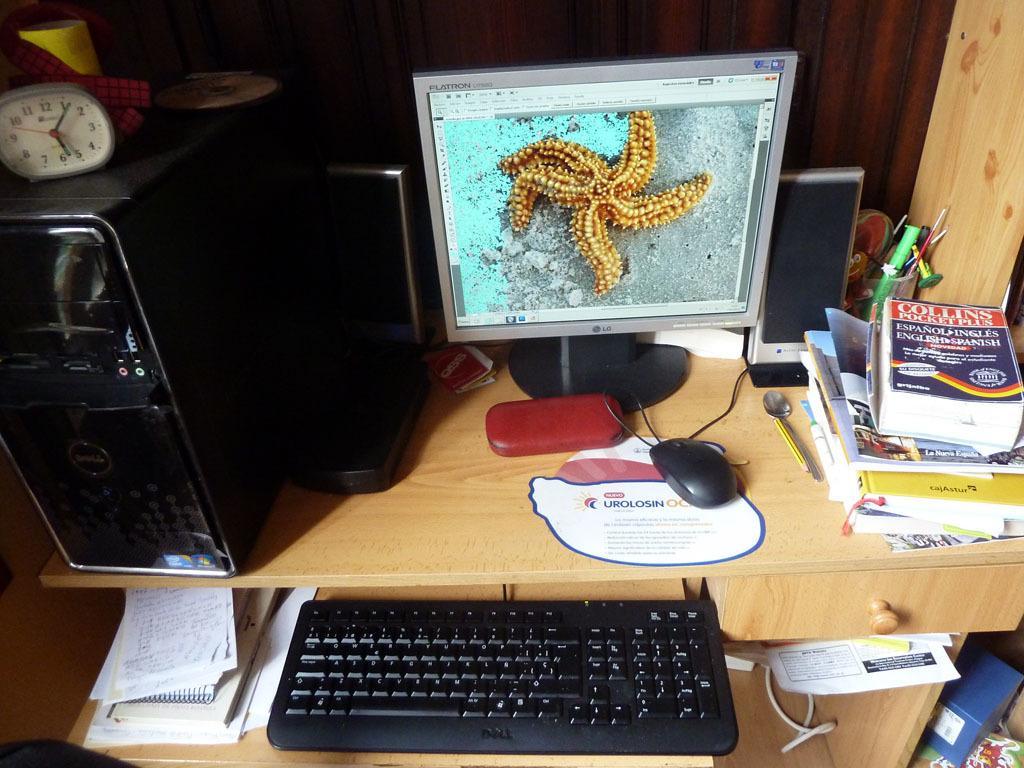Please provide a concise description of this image. In this picture we can see a table desk and on it there are books, spoon, pencil, mouse, mouse pad, keyboard, cpu and a clock on it. We can see a computer screen and ina screen its a starfish. We can see penguins in a glass. These are speakers. 